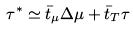<formula> <loc_0><loc_0><loc_500><loc_500>\tau ^ { \ast } \simeq \bar { t } _ { \mu } \Delta \mu + \bar { t } _ { T } \tau</formula> 